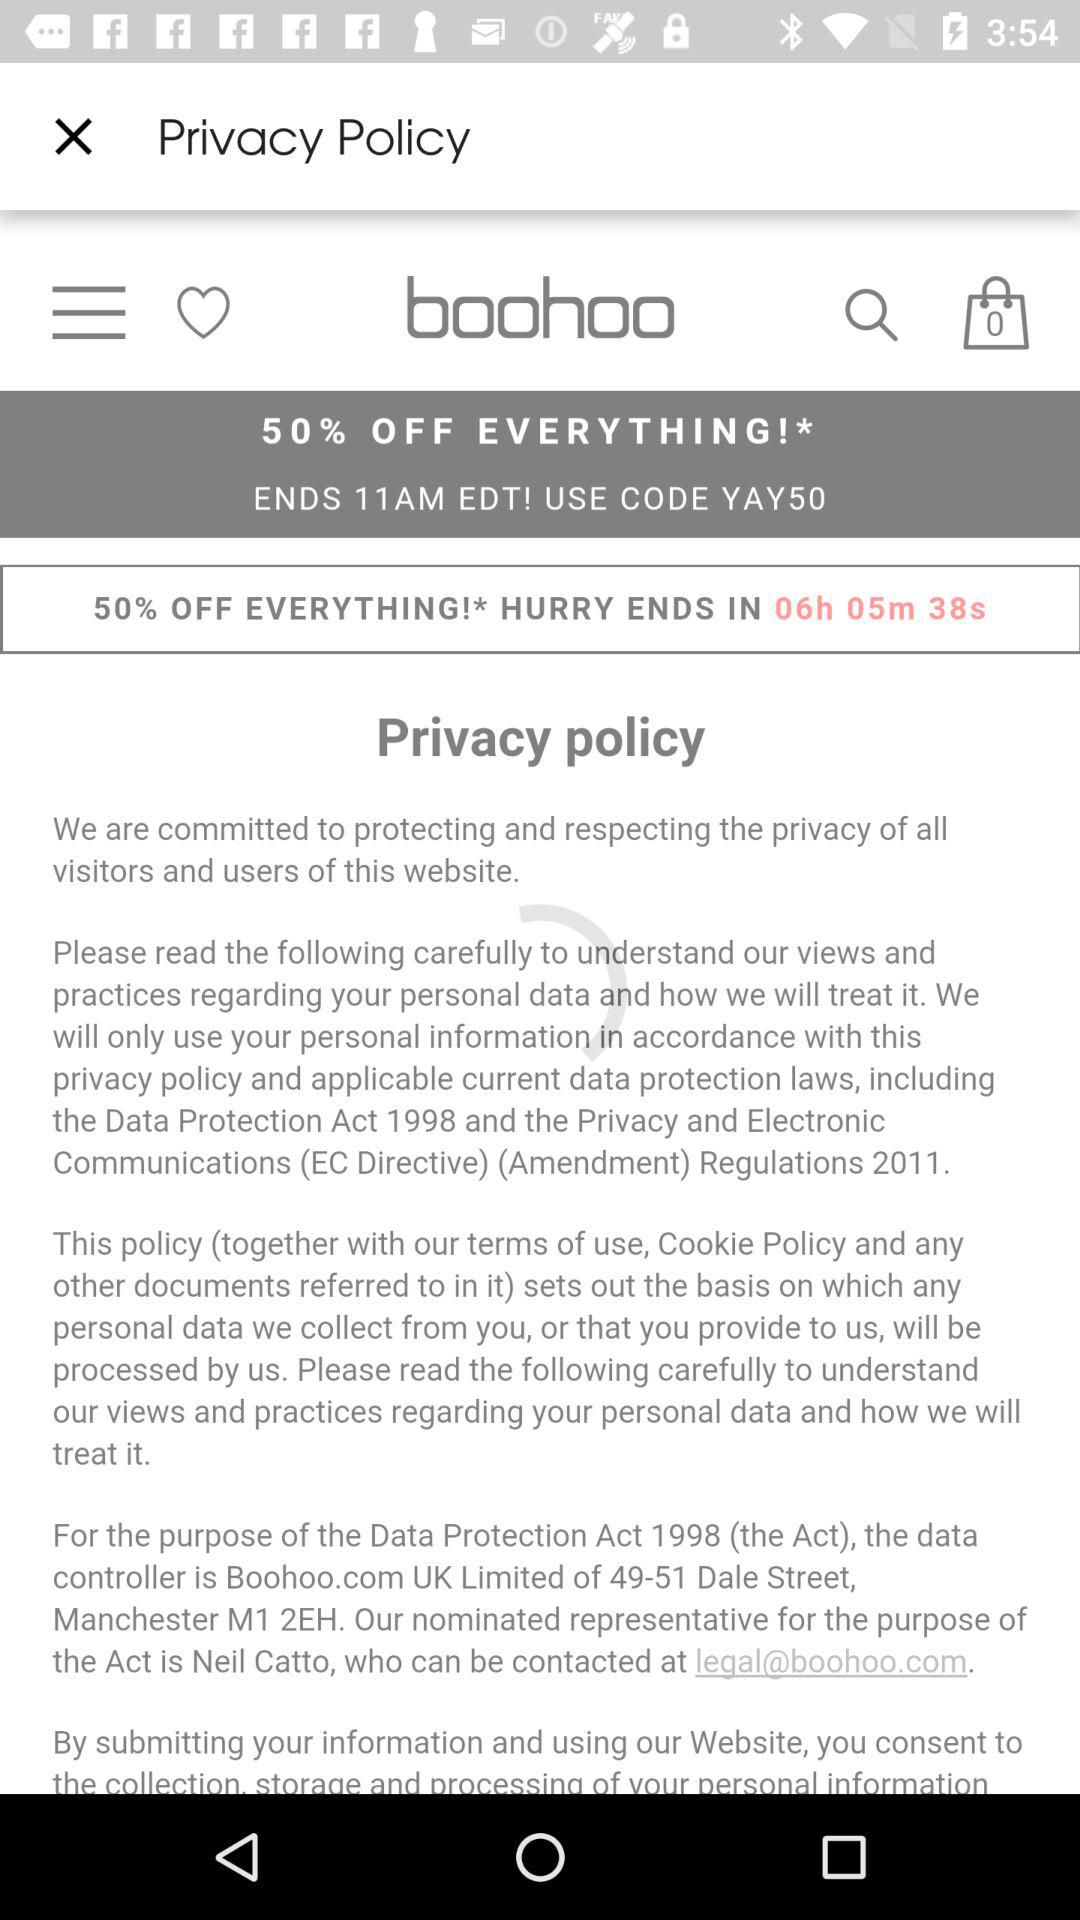What's the code for sale? The code is "YAY50". 